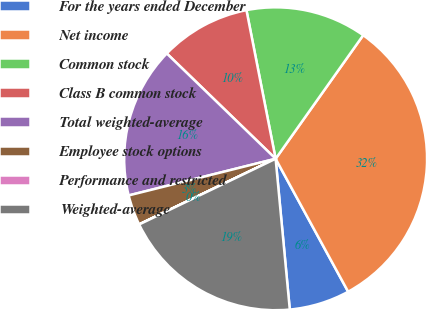Convert chart to OTSL. <chart><loc_0><loc_0><loc_500><loc_500><pie_chart><fcel>For the years ended December<fcel>Net income<fcel>Common stock<fcel>Class B common stock<fcel>Total weighted-average<fcel>Employee stock options<fcel>Performance and restricted<fcel>Weighted-average<nl><fcel>6.46%<fcel>32.24%<fcel>12.9%<fcel>9.68%<fcel>16.13%<fcel>3.24%<fcel>0.01%<fcel>19.35%<nl></chart> 